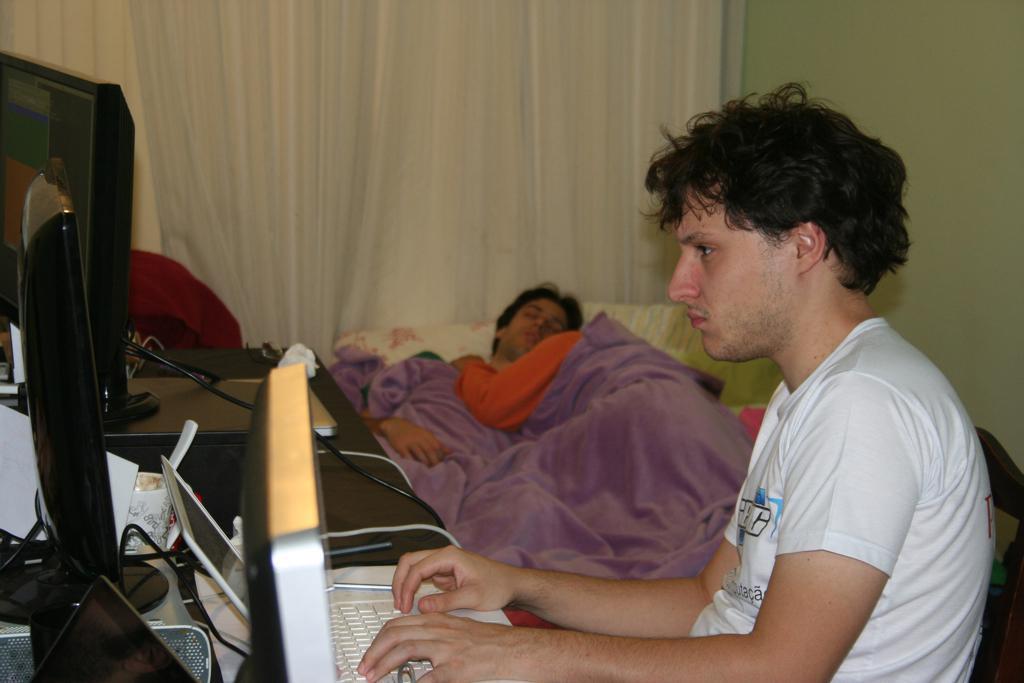Can you describe this image briefly? There is one person sitting at the bottom of this image is wearing white color t shirt. There are some laptops and some desktops are on a table on the left side of this image. There is one other person lying on the bed in the middle of this image, and there is a curtain in the background. 